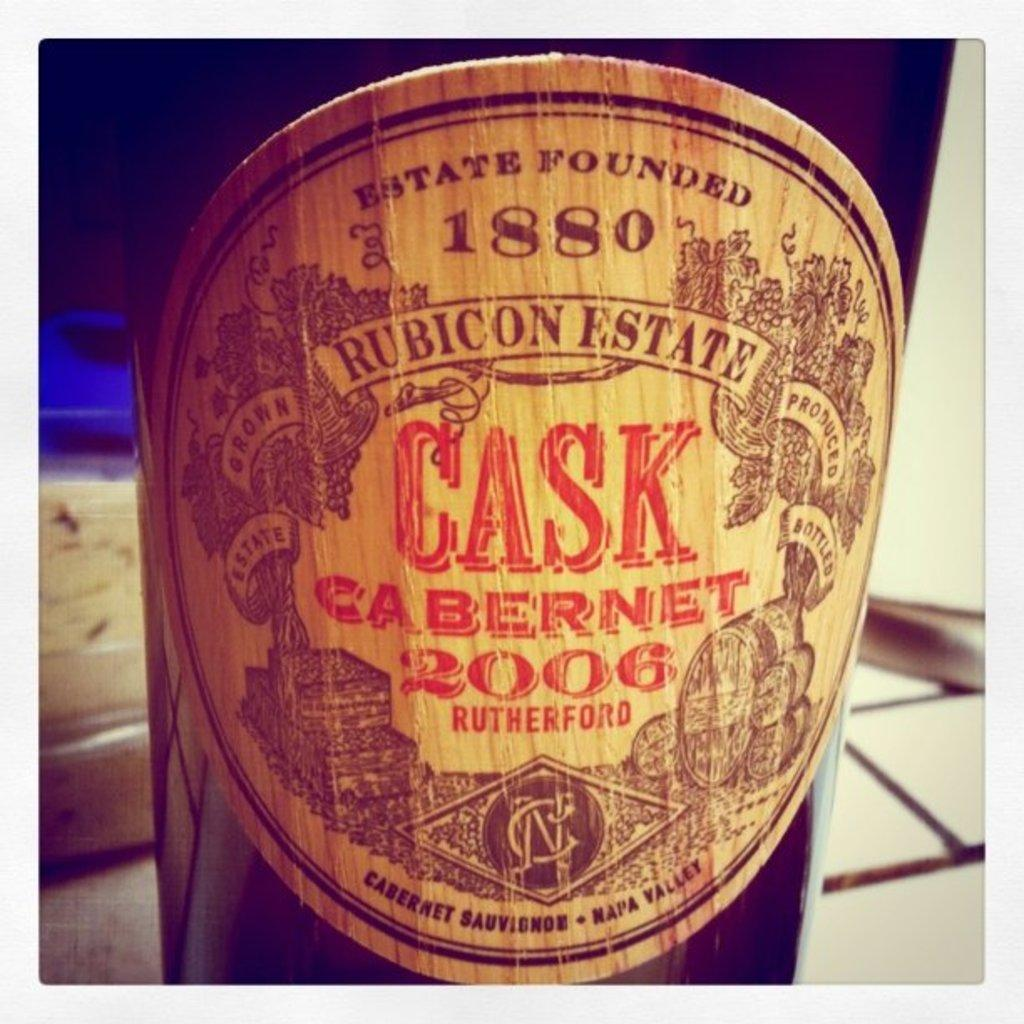Provide a one-sentence caption for the provided image. Cask Cabernet 2006 is printed on the label for this wine bottle. 